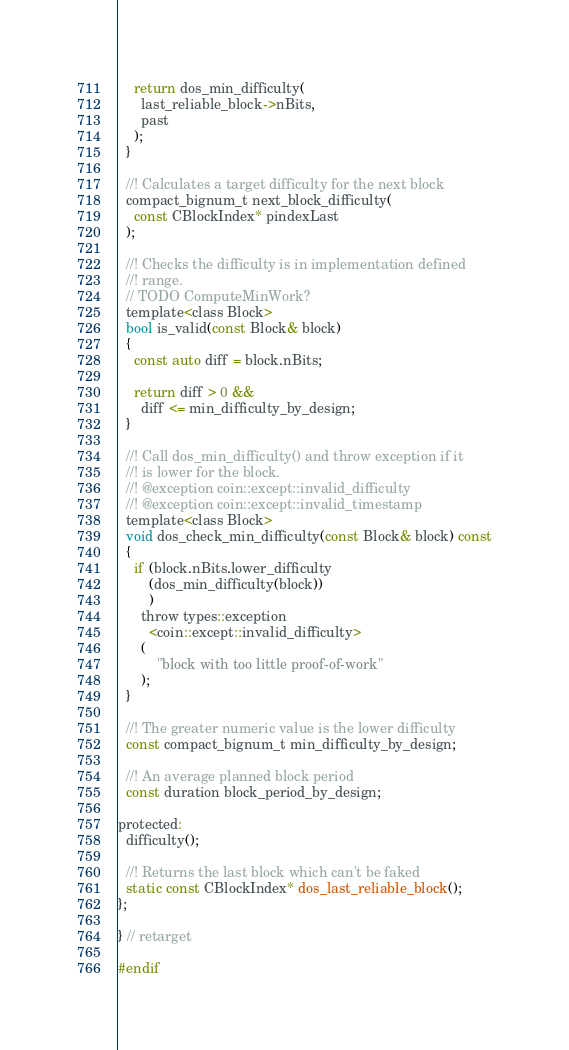<code> <loc_0><loc_0><loc_500><loc_500><_C_>    return dos_min_difficulty(
      last_reliable_block->nBits,
      past
    );
  }

  //! Calculates a target difficulty for the next block
  compact_bignum_t next_block_difficulty(
    const CBlockIndex* pindexLast
  );

  //! Checks the difficulty is in implementation defined
  //! range.
  // TODO ComputeMinWork?
  template<class Block>
  bool is_valid(const Block& block)
  {
    const auto diff = block.nBits;

    return diff > 0 && 
      diff <= min_difficulty_by_design;
  }

  //! Call dos_min_difficulty() and throw exception if it
  //! is lower for the block.
  //! @exception coin::except::invalid_difficulty
  //! @exception coin::except::invalid_timestamp
  template<class Block>
  void dos_check_min_difficulty(const Block& block) const
  {
    if (block.nBits.lower_difficulty
        (dos_min_difficulty(block))
        )
      throw types::exception
        <coin::except::invalid_difficulty>
      (
          "block with too little proof-of-work"
      );
  }

  //! The greater numeric value is the lower difficulty
  const compact_bignum_t min_difficulty_by_design;

  //! An average planned block period
  const duration block_period_by_design;

protected:
  difficulty();

  //! Returns the last block which can't be faked
  static const CBlockIndex* dos_last_reliable_block();
};

} // retarget

#endif
</code> 